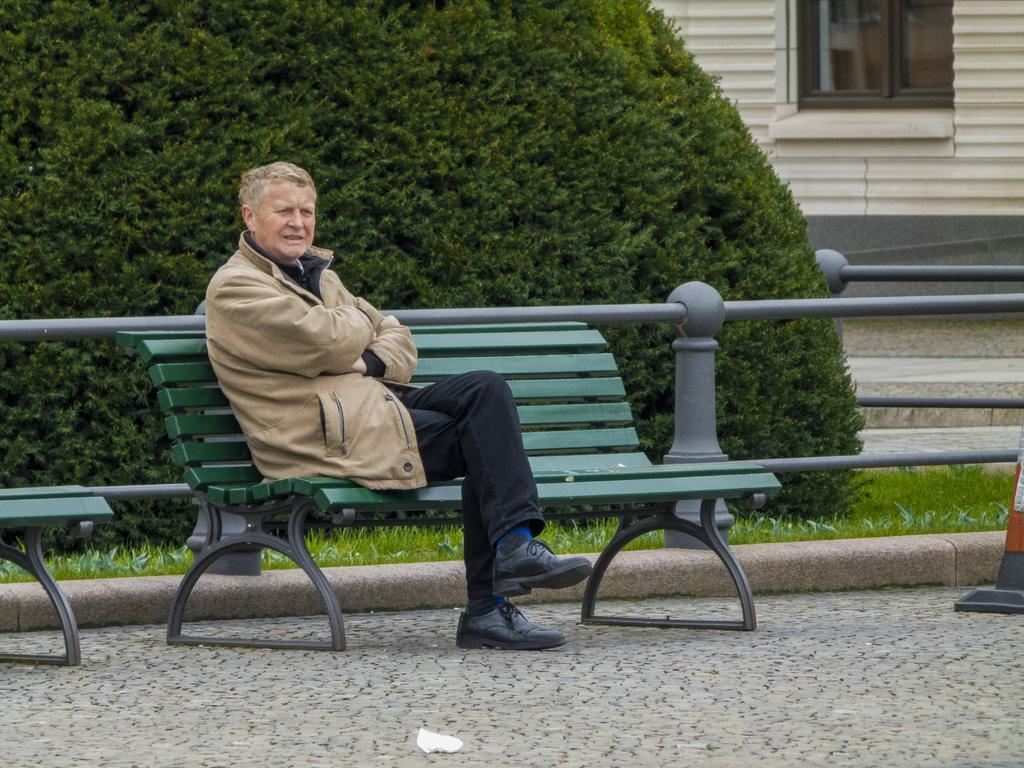In one or two sentences, can you explain what this image depicts? In this image in the middle there is a person sitting on bench, back side of bench there is a bush,wall, window,fence, on the right side there is a stopper, on the left side there is a bench. 